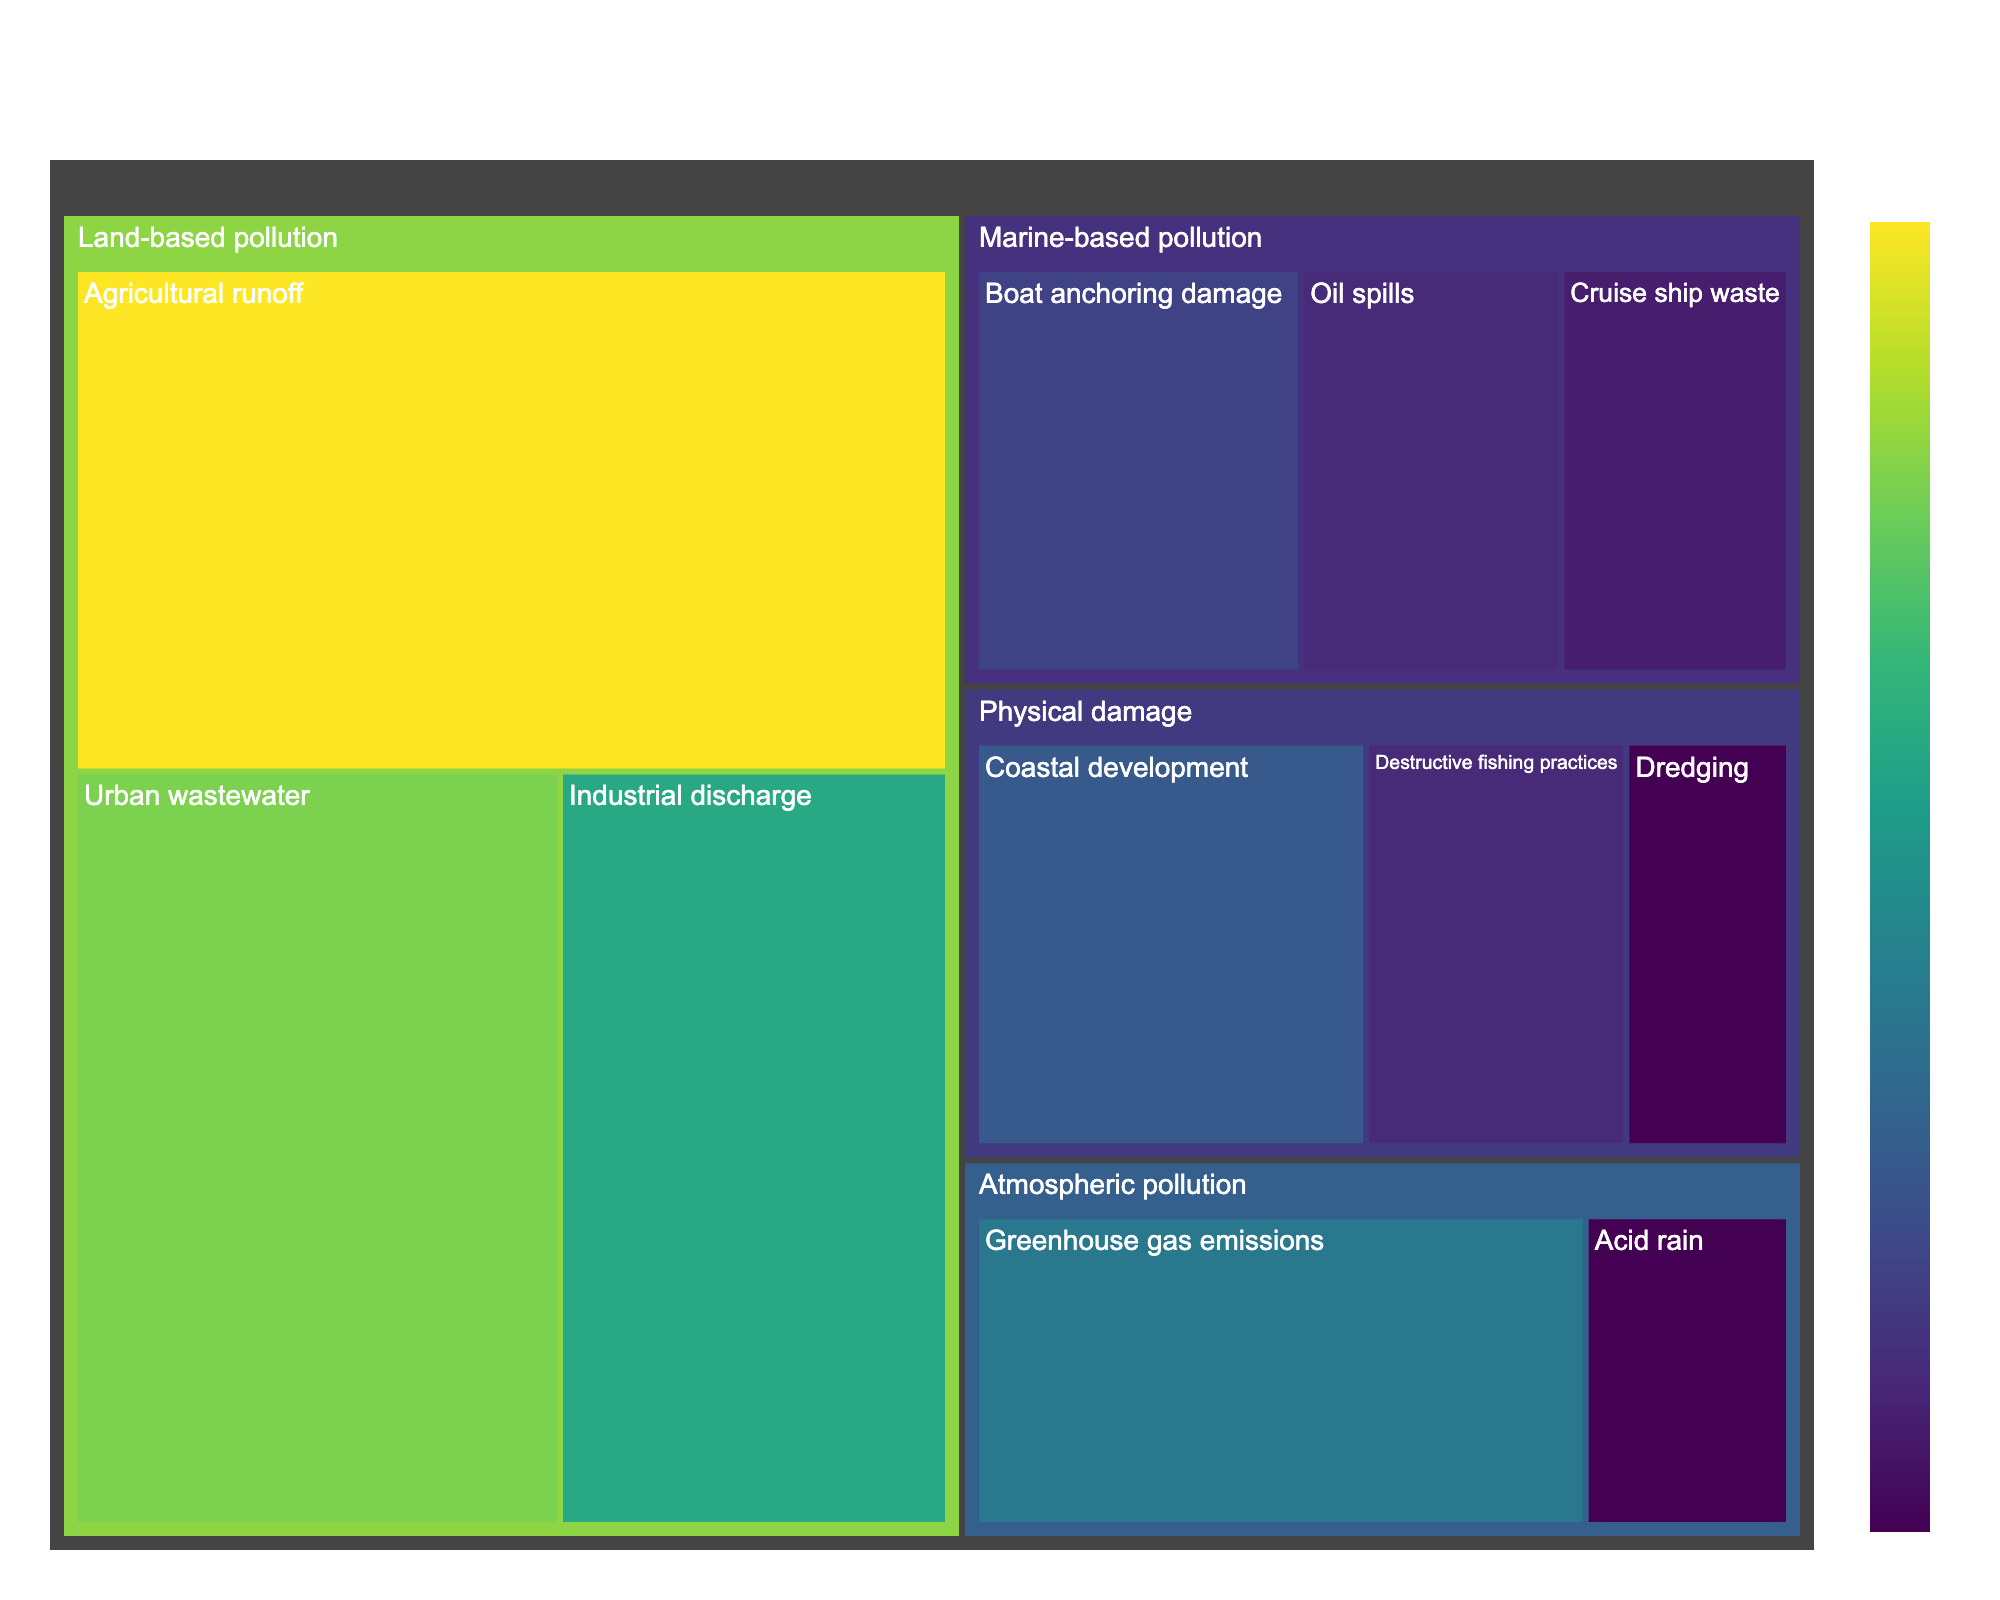What is the most significant subcategory under land-based pollution? The largest subcategory block under the land-based pollution category is Agricultural runoff, indicating its value of 30.
Answer: Agricultural runoff Which type of pollution has the smallest overall contribution? To determine the smallest contribution, compare the total values aggregated for each category. The atmospheric pollution category has the smallest sum of 20 (15+5).
Answer: Atmospheric pollution How does the value of urban wastewater compare to cruise ship waste? Find the figures corresponding to urban wastewater under land-based pollution and cruise ship waste under marine-based pollution: 25 for urban wastewater vs. 7 for cruise ship waste.
Answer: Urban wastewater is 18 higher than cruise ship waste What proportion of land-based pollution stems from agricultural runoff? To find the proportion, divide the value for agricultural runoff (30) by the sum of all land-based pollution values (75). The calculation is 30/75 = 0.4, which converts to a percentage.
Answer: 40% Which subcategory has a higher impact: coastal development or greenhouse gas emissions? Locate the value for coastal development under physical damage (12) and for greenhouse gas emissions under atmospheric pollution (15). 15 is greater than 12.
Answer: Greenhouse gas emissions What is the difference in value between oil spills and destructive fishing practices? Identify the values: oil spills (8) and destructive fishing practices (8). The difference is the result of subtracting the smaller value from the larger value, which is 8-8.
Answer: 0 Which category has more diverse pollution sources: marine-based pollution or physical damage? Count the number of subcategories under marine-based pollution (3 subcategories) and physical damage (3 subcategories). Both have the same number of subcategories.
Answer: Both have 3 subcategories What is the least impactful subcategory under atmospheric pollution? Compare the values under atmospheric pollution: greenhouse gas emissions (15) and acid rain (5). The smaller value, acid rain, indicates a lesser impact.
Answer: Acid rain 